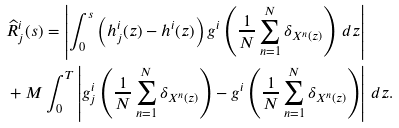<formula> <loc_0><loc_0><loc_500><loc_500>& \widehat { R } _ { j } ^ { i } ( s ) = \left | \int _ { 0 } ^ { s } \left ( h _ { j } ^ { i } ( z ) - h ^ { i } ( z ) \right ) g ^ { i } \left ( \frac { 1 } { N } \sum _ { n = 1 } ^ { N } \delta _ { X ^ { n } ( z ) } \right ) \, d z \right | \\ & + M \int _ { 0 } ^ { T } \left | g ^ { i } _ { j } \left ( \frac { 1 } { N } \sum _ { n = 1 } ^ { N } \delta _ { X ^ { n } ( z ) } \right ) - g ^ { i } \left ( \frac { 1 } { N } \sum _ { n = 1 } ^ { N } \delta _ { X ^ { n } ( z ) } \right ) \right | \, d z .</formula> 